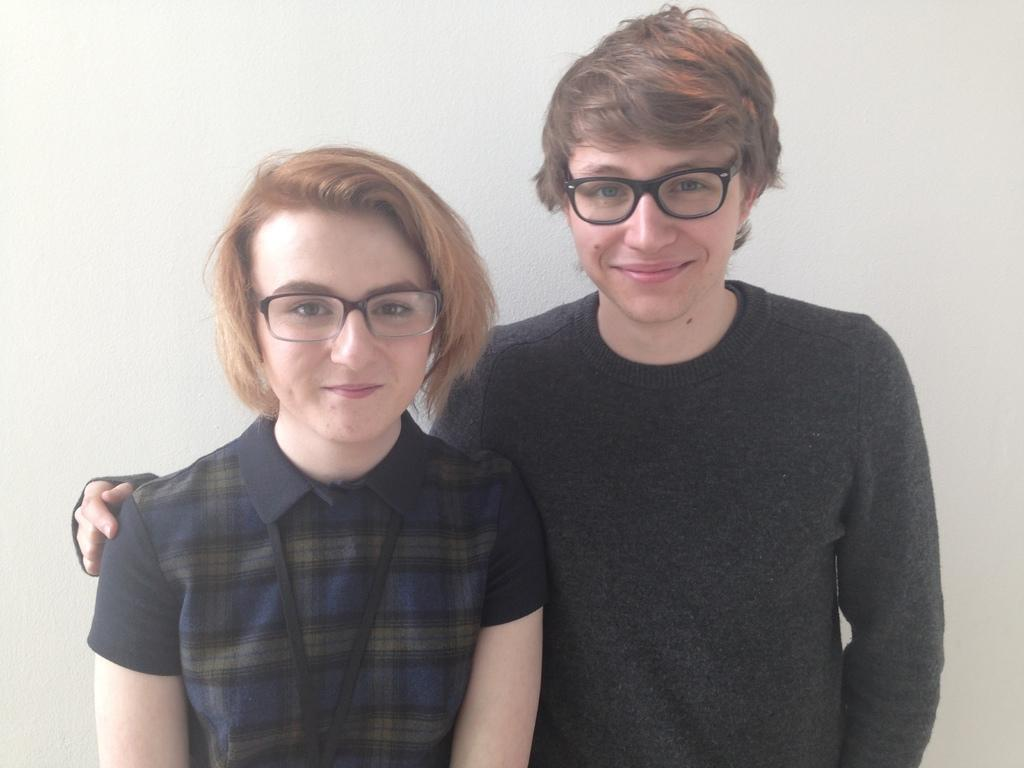How many people are present in the image? There are two people in the image. What are the people wearing that is visible in the image? Both people are wearing spectacles. What position are the people in the image? The people are standing. What can be seen in the background of the image? There is a wall in the background of the image. What type of powder is being used by the people in the image? There is no powder visible in the image; the people are wearing spectacles and standing. 